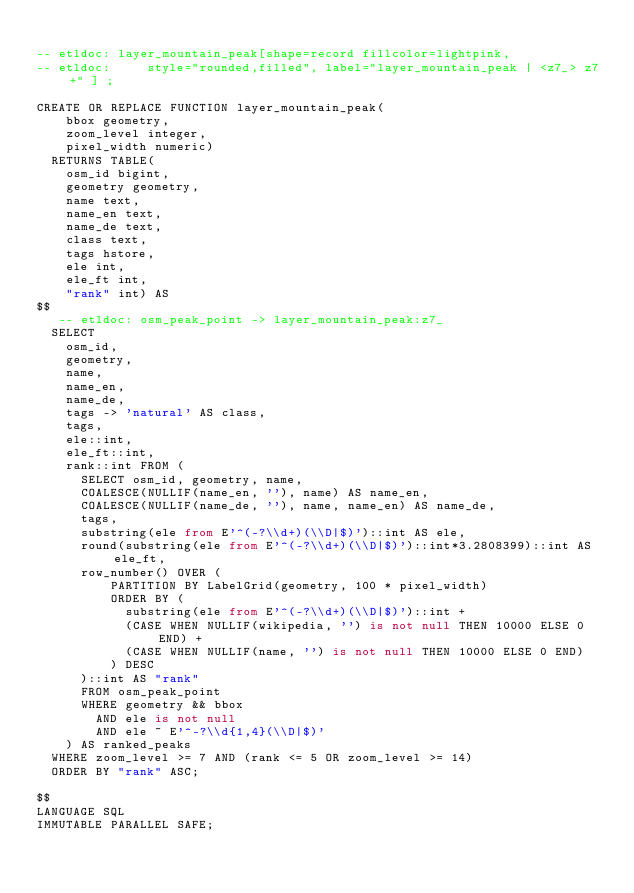Convert code to text. <code><loc_0><loc_0><loc_500><loc_500><_SQL_>
-- etldoc: layer_mountain_peak[shape=record fillcolor=lightpink,
-- etldoc:     style="rounded,filled", label="layer_mountain_peak | <z7_> z7+" ] ;

CREATE OR REPLACE FUNCTION layer_mountain_peak(
    bbox geometry,
    zoom_level integer,
    pixel_width numeric)
  RETURNS TABLE(
    osm_id bigint,
    geometry geometry,
    name text,
    name_en text,
    name_de text,
    class text,
    tags hstore,
    ele int,
    ele_ft int,
    "rank" int) AS
$$
   -- etldoc: osm_peak_point -> layer_mountain_peak:z7_
  SELECT
    osm_id,
    geometry,
    name,
    name_en,
    name_de,
    tags -> 'natural' AS class,
    tags,
    ele::int,
    ele_ft::int,
    rank::int FROM (
      SELECT osm_id, geometry, name,
      COALESCE(NULLIF(name_en, ''), name) AS name_en,
      COALESCE(NULLIF(name_de, ''), name, name_en) AS name_de,
      tags,
      substring(ele from E'^(-?\\d+)(\\D|$)')::int AS ele,
      round(substring(ele from E'^(-?\\d+)(\\D|$)')::int*3.2808399)::int AS ele_ft,
      row_number() OVER (
          PARTITION BY LabelGrid(geometry, 100 * pixel_width)
          ORDER BY (
            substring(ele from E'^(-?\\d+)(\\D|$)')::int +
            (CASE WHEN NULLIF(wikipedia, '') is not null THEN 10000 ELSE 0 END) +
            (CASE WHEN NULLIF(name, '') is not null THEN 10000 ELSE 0 END)
          ) DESC
      )::int AS "rank"
      FROM osm_peak_point
      WHERE geometry && bbox
        AND ele is not null
        AND ele ~ E'^-?\\d{1,4}(\\D|$)'
    ) AS ranked_peaks
  WHERE zoom_level >= 7 AND (rank <= 5 OR zoom_level >= 14)
  ORDER BY "rank" ASC;

$$
LANGUAGE SQL
IMMUTABLE PARALLEL SAFE;
</code> 